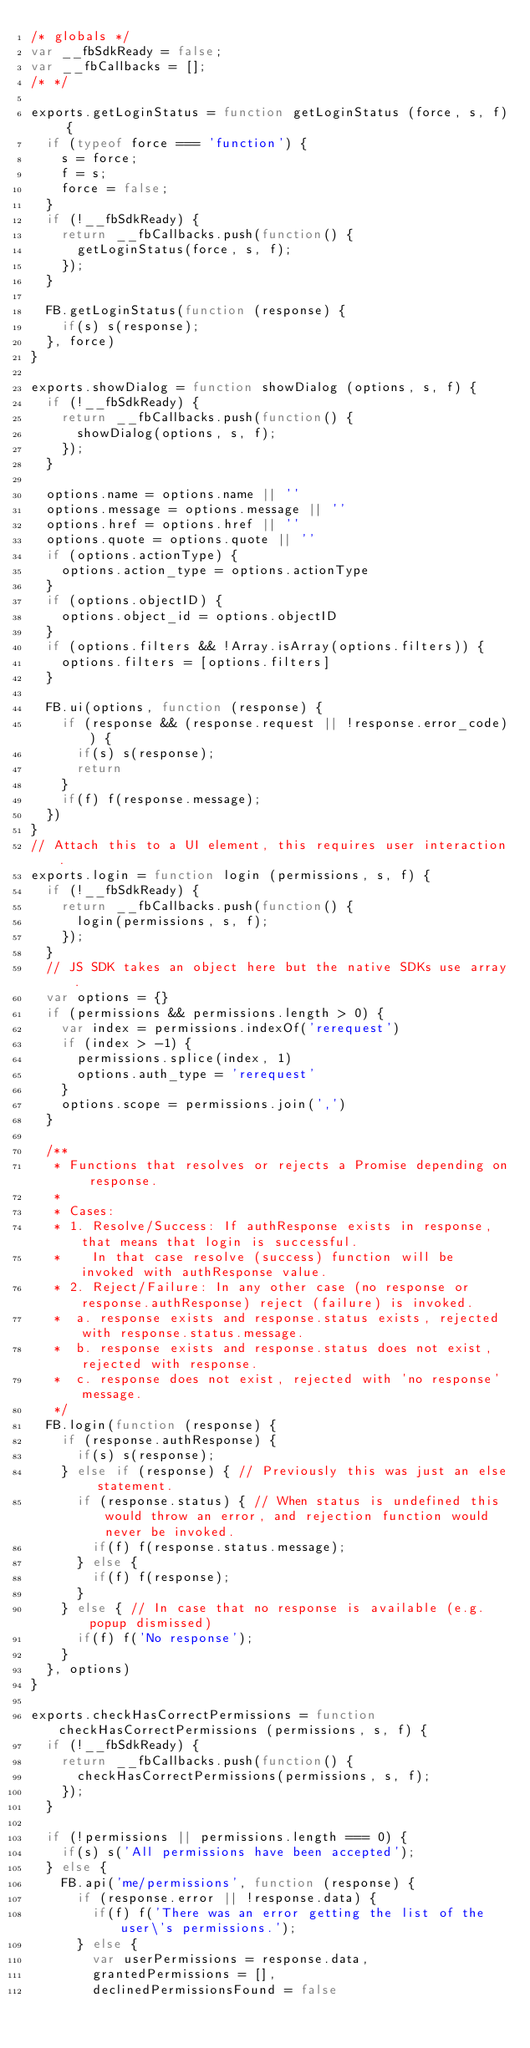Convert code to text. <code><loc_0><loc_0><loc_500><loc_500><_JavaScript_>/* globals */
var __fbSdkReady = false;
var __fbCallbacks = [];
/* */

exports.getLoginStatus = function getLoginStatus (force, s, f) {
  if (typeof force === 'function') {
    s = force;
    f = s;
    force = false;
  }
  if (!__fbSdkReady) {
    return __fbCallbacks.push(function() {
      getLoginStatus(force, s, f);
    });
  }

  FB.getLoginStatus(function (response) {
    if(s) s(response);
  }, force)
}

exports.showDialog = function showDialog (options, s, f) {
  if (!__fbSdkReady) {
    return __fbCallbacks.push(function() {
      showDialog(options, s, f);
    });
  }

  options.name = options.name || ''
  options.message = options.message || ''
  options.href = options.href || ''
  options.quote = options.quote || ''
  if (options.actionType) {
    options.action_type = options.actionType
  }
  if (options.objectID) {
    options.object_id = options.objectID
  }
  if (options.filters && !Array.isArray(options.filters)) {
    options.filters = [options.filters]
  }

  FB.ui(options, function (response) {
    if (response && (response.request || !response.error_code)) {
      if(s) s(response);
      return
    }
    if(f) f(response.message);
  })
}
// Attach this to a UI element, this requires user interaction.
exports.login = function login (permissions, s, f) {
  if (!__fbSdkReady) {
    return __fbCallbacks.push(function() {
      login(permissions, s, f);
    });
  }
  // JS SDK takes an object here but the native SDKs use array.
  var options = {}
  if (permissions && permissions.length > 0) {
    var index = permissions.indexOf('rerequest')
    if (index > -1) {
      permissions.splice(index, 1)
      options.auth_type = 'rerequest'
    }
    options.scope = permissions.join(',')
  }

  /**
   * Functions that resolves or rejects a Promise depending on response.
   *
   * Cases:
   * 1. Resolve/Success: If authResponse exists in response, that means that login is successful.
   *    In that case resolve (success) function will be invoked with authResponse value.
   * 2. Reject/Failure: In any other case (no response or response.authResponse) reject (failure) is invoked.
   *  a. response exists and response.status exists, rejected with response.status.message.
   *  b. response exists and response.status does not exist, rejected with response.
   *  c. response does not exist, rejected with 'no response' message.
   */
  FB.login(function (response) {
    if (response.authResponse) {
      if(s) s(response);
    } else if (response) { // Previously this was just an else statement.
      if (response.status) { // When status is undefined this would throw an error, and rejection function would never be invoked.
        if(f) f(response.status.message);
      } else {
        if(f) f(response);
      }
    } else { // In case that no response is available (e.g. popup dismissed)
      if(f) f('No response');
    } 
  }, options)
}

exports.checkHasCorrectPermissions = function checkHasCorrectPermissions (permissions, s, f) {
  if (!__fbSdkReady) {
    return __fbCallbacks.push(function() {
      checkHasCorrectPermissions(permissions, s, f);
    });
  }

  if (!permissions || permissions.length === 0) {
    if(s) s('All permissions have been accepted');
  } else {
    FB.api('me/permissions', function (response) {
      if (response.error || !response.data) {
        if(f) f('There was an error getting the list of the user\'s permissions.');
      } else {
        var userPermissions = response.data, 
        grantedPermissions = [], 
        declinedPermissionsFound = false</code> 